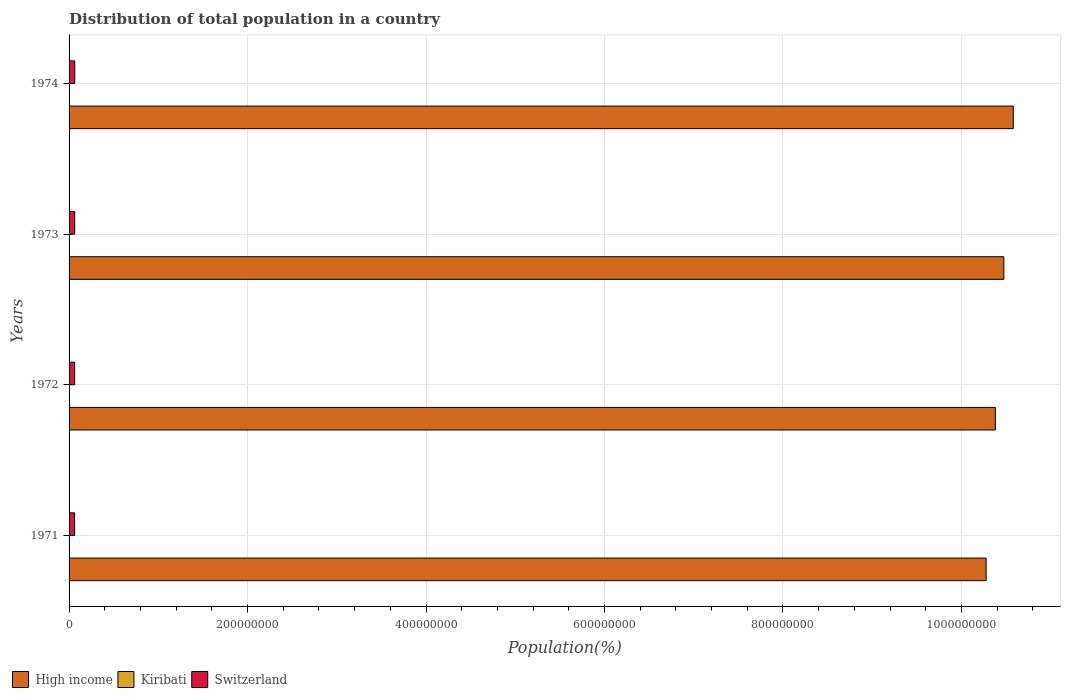How many different coloured bars are there?
Your answer should be compact. 3. How many groups of bars are there?
Your answer should be compact. 4. Are the number of bars per tick equal to the number of legend labels?
Keep it short and to the point. Yes. Are the number of bars on each tick of the Y-axis equal?
Your answer should be compact. Yes. How many bars are there on the 2nd tick from the bottom?
Your answer should be very brief. 3. What is the label of the 1st group of bars from the top?
Provide a short and direct response. 1974. In how many cases, is the number of bars for a given year not equal to the number of legend labels?
Keep it short and to the point. 0. What is the population of in Switzerland in 1972?
Ensure brevity in your answer.  6.26e+06. Across all years, what is the maximum population of in High income?
Make the answer very short. 1.06e+09. Across all years, what is the minimum population of in Kiribati?
Provide a succinct answer. 5.20e+04. In which year was the population of in High income maximum?
Give a very brief answer. 1974. What is the total population of in High income in the graph?
Make the answer very short. 4.17e+09. What is the difference between the population of in Switzerland in 1972 and that in 1973?
Ensure brevity in your answer.  -4.64e+04. What is the difference between the population of in High income in 1971 and the population of in Kiribati in 1973?
Ensure brevity in your answer.  1.03e+09. What is the average population of in Switzerland per year?
Make the answer very short. 6.28e+06. In the year 1973, what is the difference between the population of in Switzerland and population of in High income?
Offer a terse response. -1.04e+09. In how many years, is the population of in Kiribati greater than 40000000 %?
Provide a short and direct response. 0. What is the ratio of the population of in Kiribati in 1971 to that in 1973?
Your answer should be compact. 0.97. What is the difference between the highest and the second highest population of in Kiribati?
Your answer should be compact. 777. What is the difference between the highest and the lowest population of in Kiribati?
Provide a short and direct response. 2362. Is the sum of the population of in Switzerland in 1972 and 1973 greater than the maximum population of in High income across all years?
Offer a very short reply. No. What does the 2nd bar from the top in 1971 represents?
Make the answer very short. Kiribati. What does the 3rd bar from the bottom in 1974 represents?
Your answer should be very brief. Switzerland. How many bars are there?
Give a very brief answer. 12. Are all the bars in the graph horizontal?
Provide a short and direct response. Yes. What is the title of the graph?
Keep it short and to the point. Distribution of total population in a country. Does "South Africa" appear as one of the legend labels in the graph?
Your answer should be compact. No. What is the label or title of the X-axis?
Offer a terse response. Population(%). What is the Population(%) in High income in 1971?
Offer a terse response. 1.03e+09. What is the Population(%) in Kiribati in 1971?
Make the answer very short. 5.20e+04. What is the Population(%) of Switzerland in 1971?
Ensure brevity in your answer.  6.21e+06. What is the Population(%) in High income in 1972?
Make the answer very short. 1.04e+09. What is the Population(%) in Kiribati in 1972?
Your answer should be very brief. 5.28e+04. What is the Population(%) in Switzerland in 1972?
Make the answer very short. 6.26e+06. What is the Population(%) of High income in 1973?
Offer a very short reply. 1.05e+09. What is the Population(%) in Kiribati in 1973?
Your response must be concise. 5.36e+04. What is the Population(%) in Switzerland in 1973?
Offer a terse response. 6.31e+06. What is the Population(%) of High income in 1974?
Provide a succinct answer. 1.06e+09. What is the Population(%) in Kiribati in 1974?
Ensure brevity in your answer.  5.44e+04. What is the Population(%) in Switzerland in 1974?
Provide a succinct answer. 6.34e+06. Across all years, what is the maximum Population(%) in High income?
Your answer should be very brief. 1.06e+09. Across all years, what is the maximum Population(%) in Kiribati?
Give a very brief answer. 5.44e+04. Across all years, what is the maximum Population(%) in Switzerland?
Provide a succinct answer. 6.34e+06. Across all years, what is the minimum Population(%) of High income?
Make the answer very short. 1.03e+09. Across all years, what is the minimum Population(%) in Kiribati?
Provide a succinct answer. 5.20e+04. Across all years, what is the minimum Population(%) of Switzerland?
Your answer should be compact. 6.21e+06. What is the total Population(%) in High income in the graph?
Your answer should be very brief. 4.17e+09. What is the total Population(%) in Kiribati in the graph?
Offer a very short reply. 2.13e+05. What is the total Population(%) in Switzerland in the graph?
Give a very brief answer. 2.51e+07. What is the difference between the Population(%) of High income in 1971 and that in 1972?
Your response must be concise. -1.04e+07. What is the difference between the Population(%) of Kiribati in 1971 and that in 1972?
Your answer should be very brief. -803. What is the difference between the Population(%) in Switzerland in 1971 and that in 1972?
Provide a succinct answer. -4.76e+04. What is the difference between the Population(%) in High income in 1971 and that in 1973?
Your answer should be very brief. -1.99e+07. What is the difference between the Population(%) of Kiribati in 1971 and that in 1973?
Provide a short and direct response. -1585. What is the difference between the Population(%) in Switzerland in 1971 and that in 1973?
Offer a terse response. -9.39e+04. What is the difference between the Population(%) of High income in 1971 and that in 1974?
Give a very brief answer. -3.04e+07. What is the difference between the Population(%) of Kiribati in 1971 and that in 1974?
Provide a short and direct response. -2362. What is the difference between the Population(%) in Switzerland in 1971 and that in 1974?
Your answer should be very brief. -1.28e+05. What is the difference between the Population(%) in High income in 1972 and that in 1973?
Keep it short and to the point. -9.50e+06. What is the difference between the Population(%) of Kiribati in 1972 and that in 1973?
Keep it short and to the point. -782. What is the difference between the Population(%) in Switzerland in 1972 and that in 1973?
Give a very brief answer. -4.64e+04. What is the difference between the Population(%) in High income in 1972 and that in 1974?
Offer a terse response. -2.01e+07. What is the difference between the Population(%) in Kiribati in 1972 and that in 1974?
Provide a short and direct response. -1559. What is the difference between the Population(%) of Switzerland in 1972 and that in 1974?
Provide a succinct answer. -8.04e+04. What is the difference between the Population(%) in High income in 1973 and that in 1974?
Keep it short and to the point. -1.06e+07. What is the difference between the Population(%) in Kiribati in 1973 and that in 1974?
Give a very brief answer. -777. What is the difference between the Population(%) of Switzerland in 1973 and that in 1974?
Offer a very short reply. -3.41e+04. What is the difference between the Population(%) in High income in 1971 and the Population(%) in Kiribati in 1972?
Give a very brief answer. 1.03e+09. What is the difference between the Population(%) in High income in 1971 and the Population(%) in Switzerland in 1972?
Make the answer very short. 1.02e+09. What is the difference between the Population(%) in Kiribati in 1971 and the Population(%) in Switzerland in 1972?
Give a very brief answer. -6.21e+06. What is the difference between the Population(%) in High income in 1971 and the Population(%) in Kiribati in 1973?
Keep it short and to the point. 1.03e+09. What is the difference between the Population(%) in High income in 1971 and the Population(%) in Switzerland in 1973?
Keep it short and to the point. 1.02e+09. What is the difference between the Population(%) in Kiribati in 1971 and the Population(%) in Switzerland in 1973?
Your response must be concise. -6.26e+06. What is the difference between the Population(%) in High income in 1971 and the Population(%) in Kiribati in 1974?
Offer a terse response. 1.03e+09. What is the difference between the Population(%) in High income in 1971 and the Population(%) in Switzerland in 1974?
Make the answer very short. 1.02e+09. What is the difference between the Population(%) in Kiribati in 1971 and the Population(%) in Switzerland in 1974?
Give a very brief answer. -6.29e+06. What is the difference between the Population(%) of High income in 1972 and the Population(%) of Kiribati in 1973?
Offer a very short reply. 1.04e+09. What is the difference between the Population(%) in High income in 1972 and the Population(%) in Switzerland in 1973?
Ensure brevity in your answer.  1.03e+09. What is the difference between the Population(%) in Kiribati in 1972 and the Population(%) in Switzerland in 1973?
Your answer should be compact. -6.25e+06. What is the difference between the Population(%) of High income in 1972 and the Population(%) of Kiribati in 1974?
Keep it short and to the point. 1.04e+09. What is the difference between the Population(%) in High income in 1972 and the Population(%) in Switzerland in 1974?
Make the answer very short. 1.03e+09. What is the difference between the Population(%) of Kiribati in 1972 and the Population(%) of Switzerland in 1974?
Offer a very short reply. -6.29e+06. What is the difference between the Population(%) of High income in 1973 and the Population(%) of Kiribati in 1974?
Offer a terse response. 1.05e+09. What is the difference between the Population(%) in High income in 1973 and the Population(%) in Switzerland in 1974?
Provide a succinct answer. 1.04e+09. What is the difference between the Population(%) of Kiribati in 1973 and the Population(%) of Switzerland in 1974?
Make the answer very short. -6.29e+06. What is the average Population(%) of High income per year?
Provide a succinct answer. 1.04e+09. What is the average Population(%) in Kiribati per year?
Make the answer very short. 5.32e+04. What is the average Population(%) of Switzerland per year?
Your response must be concise. 6.28e+06. In the year 1971, what is the difference between the Population(%) of High income and Population(%) of Kiribati?
Offer a very short reply. 1.03e+09. In the year 1971, what is the difference between the Population(%) of High income and Population(%) of Switzerland?
Your answer should be very brief. 1.02e+09. In the year 1971, what is the difference between the Population(%) of Kiribati and Population(%) of Switzerland?
Ensure brevity in your answer.  -6.16e+06. In the year 1972, what is the difference between the Population(%) of High income and Population(%) of Kiribati?
Make the answer very short. 1.04e+09. In the year 1972, what is the difference between the Population(%) in High income and Population(%) in Switzerland?
Give a very brief answer. 1.03e+09. In the year 1972, what is the difference between the Population(%) of Kiribati and Population(%) of Switzerland?
Keep it short and to the point. -6.21e+06. In the year 1973, what is the difference between the Population(%) of High income and Population(%) of Kiribati?
Ensure brevity in your answer.  1.05e+09. In the year 1973, what is the difference between the Population(%) in High income and Population(%) in Switzerland?
Offer a very short reply. 1.04e+09. In the year 1973, what is the difference between the Population(%) in Kiribati and Population(%) in Switzerland?
Provide a short and direct response. -6.25e+06. In the year 1974, what is the difference between the Population(%) in High income and Population(%) in Kiribati?
Your answer should be very brief. 1.06e+09. In the year 1974, what is the difference between the Population(%) in High income and Population(%) in Switzerland?
Your answer should be very brief. 1.05e+09. In the year 1974, what is the difference between the Population(%) of Kiribati and Population(%) of Switzerland?
Your answer should be very brief. -6.29e+06. What is the ratio of the Population(%) of High income in 1971 to that in 1972?
Offer a very short reply. 0.99. What is the ratio of the Population(%) in Kiribati in 1971 to that in 1972?
Offer a very short reply. 0.98. What is the ratio of the Population(%) in Kiribati in 1971 to that in 1973?
Your response must be concise. 0.97. What is the ratio of the Population(%) of Switzerland in 1971 to that in 1973?
Provide a succinct answer. 0.99. What is the ratio of the Population(%) of High income in 1971 to that in 1974?
Make the answer very short. 0.97. What is the ratio of the Population(%) of Kiribati in 1971 to that in 1974?
Your answer should be compact. 0.96. What is the ratio of the Population(%) of Switzerland in 1971 to that in 1974?
Offer a terse response. 0.98. What is the ratio of the Population(%) of High income in 1972 to that in 1973?
Provide a short and direct response. 0.99. What is the ratio of the Population(%) of Kiribati in 1972 to that in 1973?
Keep it short and to the point. 0.99. What is the ratio of the Population(%) in Switzerland in 1972 to that in 1973?
Your answer should be very brief. 0.99. What is the ratio of the Population(%) of Kiribati in 1972 to that in 1974?
Provide a succinct answer. 0.97. What is the ratio of the Population(%) in Switzerland in 1972 to that in 1974?
Offer a very short reply. 0.99. What is the ratio of the Population(%) in Kiribati in 1973 to that in 1974?
Ensure brevity in your answer.  0.99. What is the difference between the highest and the second highest Population(%) of High income?
Make the answer very short. 1.06e+07. What is the difference between the highest and the second highest Population(%) of Kiribati?
Offer a terse response. 777. What is the difference between the highest and the second highest Population(%) of Switzerland?
Your response must be concise. 3.41e+04. What is the difference between the highest and the lowest Population(%) of High income?
Your response must be concise. 3.04e+07. What is the difference between the highest and the lowest Population(%) in Kiribati?
Your answer should be very brief. 2362. What is the difference between the highest and the lowest Population(%) of Switzerland?
Offer a terse response. 1.28e+05. 